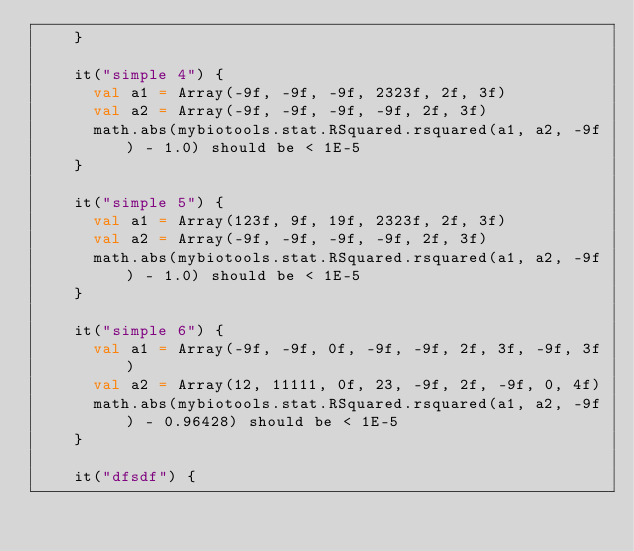Convert code to text. <code><loc_0><loc_0><loc_500><loc_500><_Scala_>    }

    it("simple 4") {
      val a1 = Array(-9f, -9f, -9f, 2323f, 2f, 3f)
      val a2 = Array(-9f, -9f, -9f, -9f, 2f, 3f)
      math.abs(mybiotools.stat.RSquared.rsquared(a1, a2, -9f) - 1.0) should be < 1E-5
    }

    it("simple 5") {
      val a1 = Array(123f, 9f, 19f, 2323f, 2f, 3f)
      val a2 = Array(-9f, -9f, -9f, -9f, 2f, 3f)
      math.abs(mybiotools.stat.RSquared.rsquared(a1, a2, -9f) - 1.0) should be < 1E-5
    }

    it("simple 6") {
      val a1 = Array(-9f, -9f, 0f, -9f, -9f, 2f, 3f, -9f, 3f)
      val a2 = Array(12, 11111, 0f, 23, -9f, 2f, -9f, 0, 4f)
      math.abs(mybiotools.stat.RSquared.rsquared(a1, a2, -9f) - 0.96428) should be < 1E-5
    }

    it("dfsdf") {</code> 